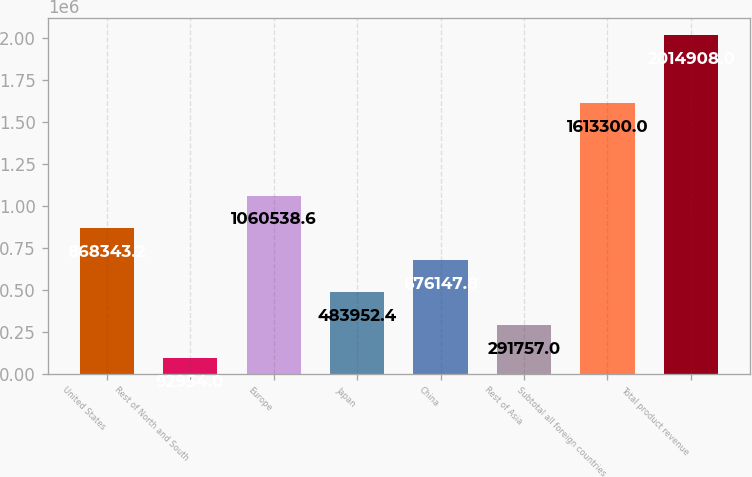<chart> <loc_0><loc_0><loc_500><loc_500><bar_chart><fcel>United States<fcel>Rest of North and South<fcel>Europe<fcel>Japan<fcel>China<fcel>Rest of Asia<fcel>Subtotal all foreign countries<fcel>Total product revenue<nl><fcel>868343<fcel>92954<fcel>1.06054e+06<fcel>483952<fcel>676148<fcel>291757<fcel>1.6133e+06<fcel>2.01491e+06<nl></chart> 